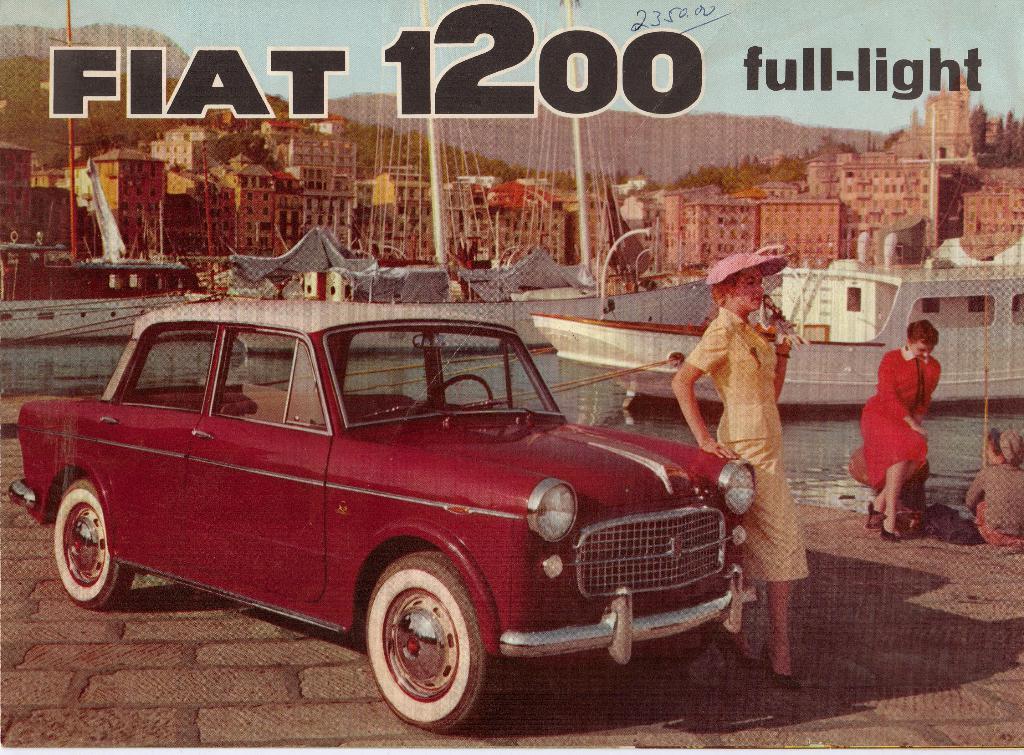How would you summarize this image in a sentence or two? In this image, we can see a poster. In the middle of the image, we can see a car which is in red color and a woman keeping her hand on the car. On the right side, we can see two people sitting, we can also see a ship which is drowning on the water. In the background, we can see some buildings, threads, poles, trees, mountains and some text on the poster. On the top, we can see a sky, at the bottom there is a water in a lake and land. 